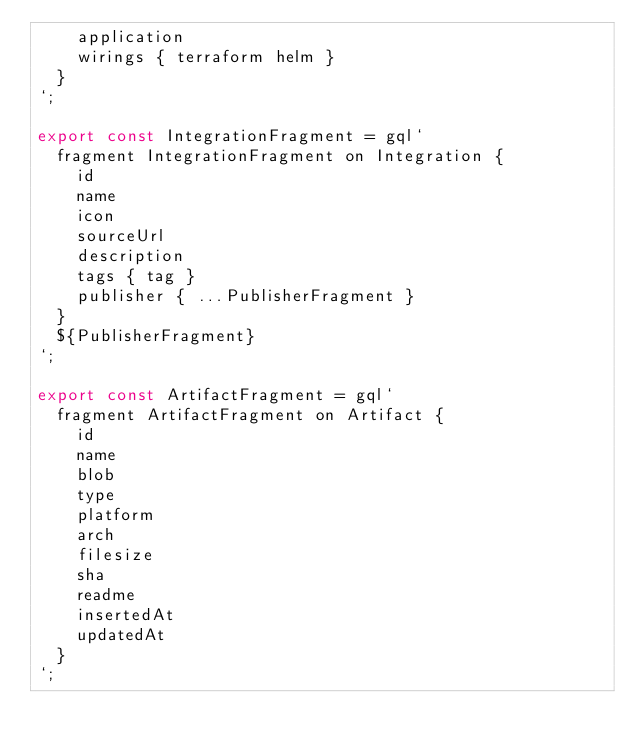<code> <loc_0><loc_0><loc_500><loc_500><_JavaScript_>    application
    wirings { terraform helm }
  }
`;

export const IntegrationFragment = gql`
  fragment IntegrationFragment on Integration {
    id
    name
    icon
    sourceUrl
    description
    tags { tag }
    publisher { ...PublisherFragment }
  }
  ${PublisherFragment}
`;

export const ArtifactFragment = gql`
  fragment ArtifactFragment on Artifact {
    id
    name
    blob
    type
    platform
    arch
    filesize
    sha
    readme
    insertedAt
    updatedAt
  }
`;</code> 